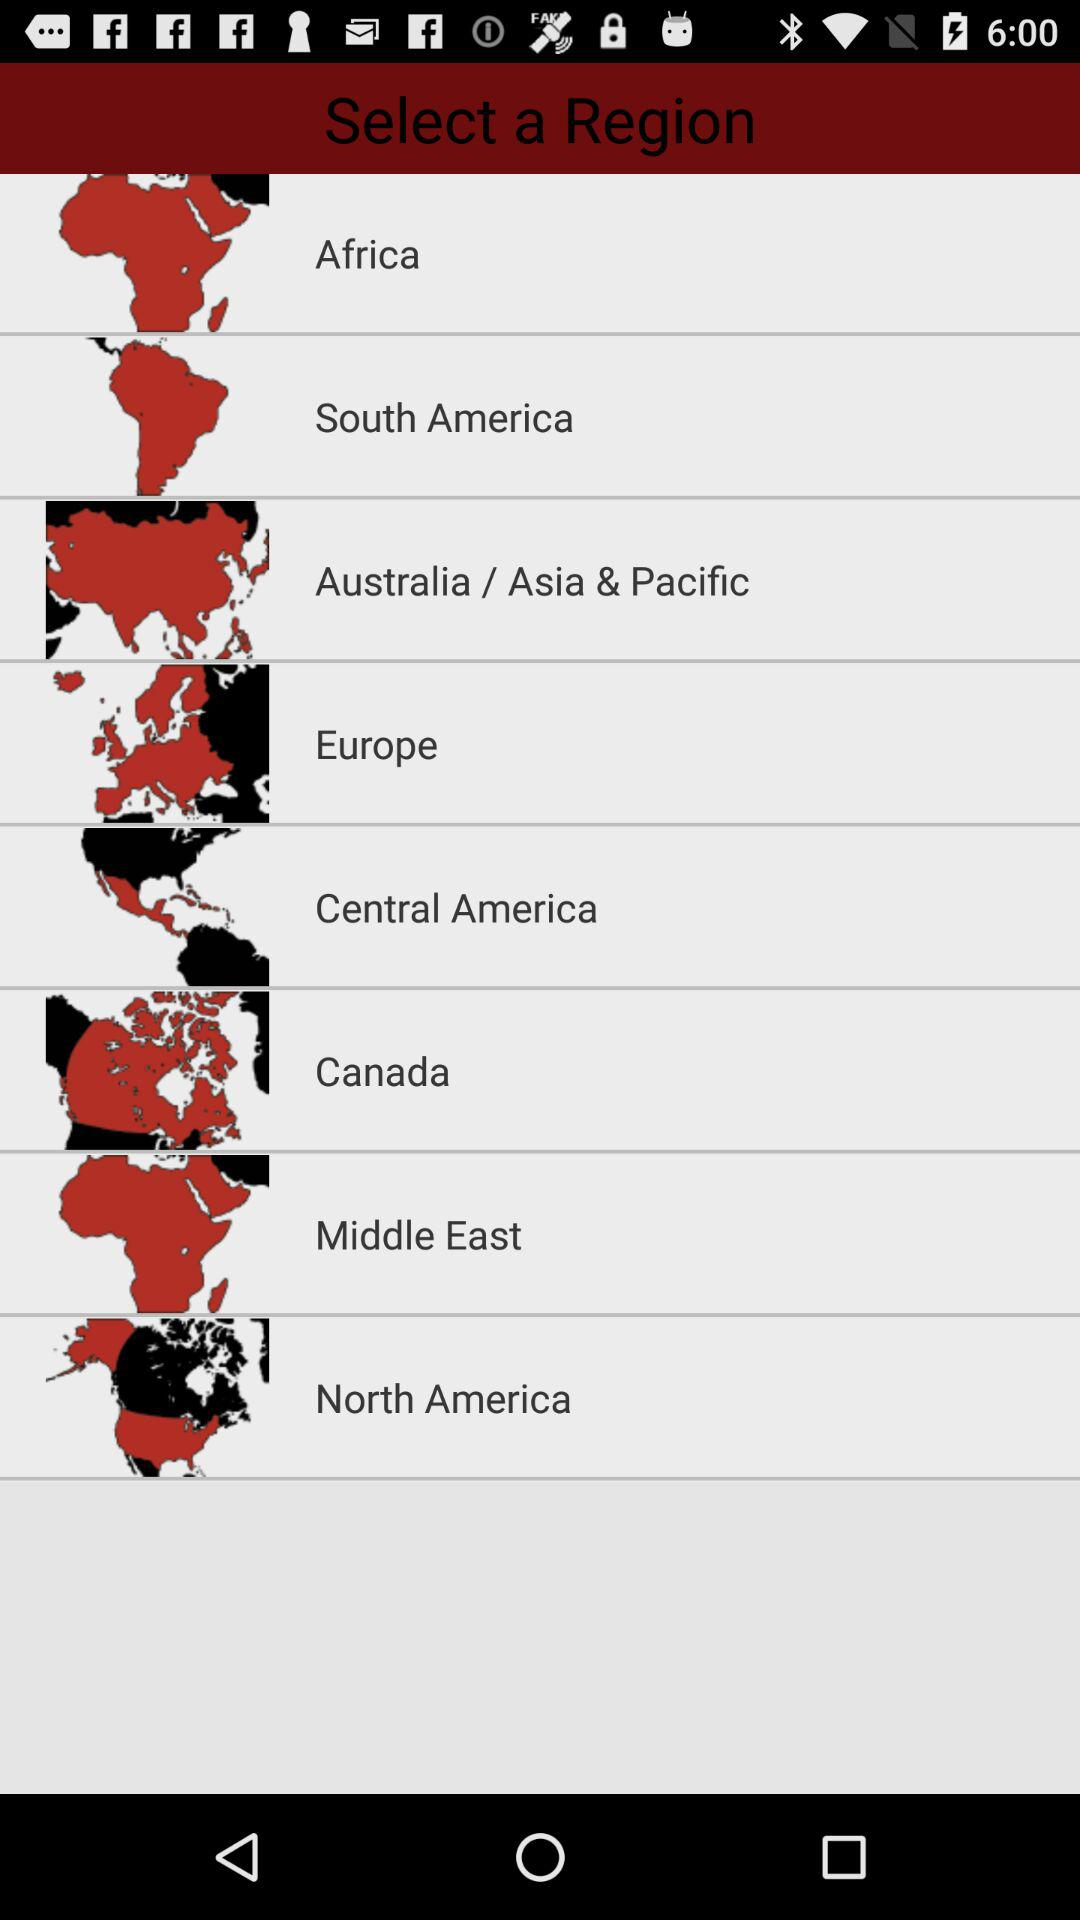How many regions are there in total?
Answer the question using a single word or phrase. 8 